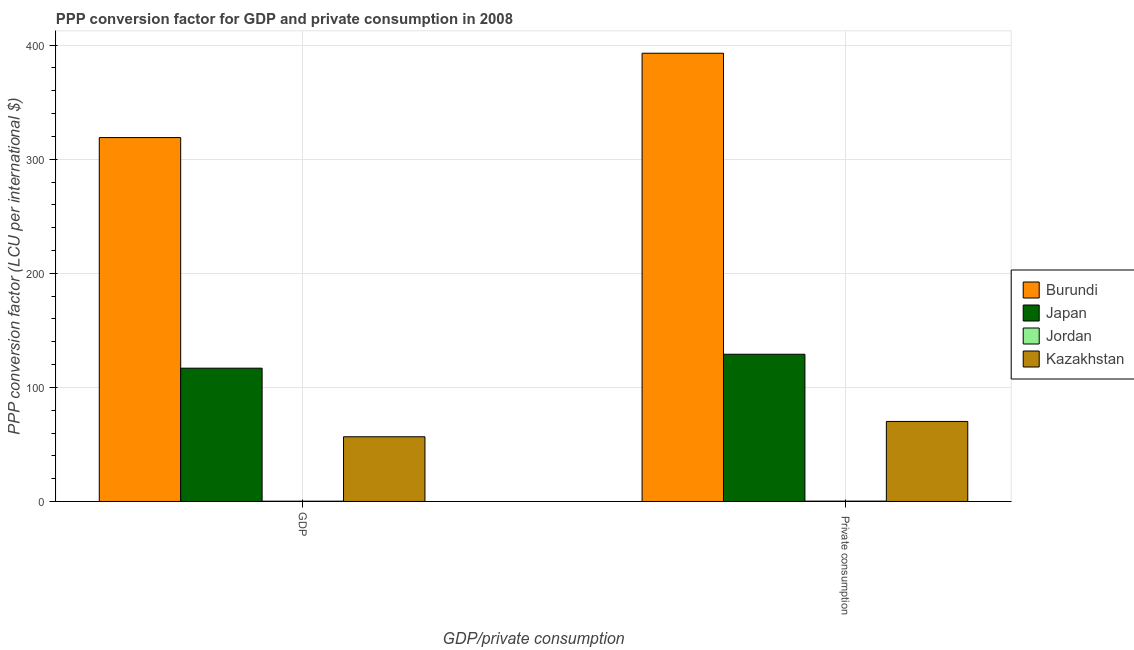How many different coloured bars are there?
Offer a very short reply. 4. How many groups of bars are there?
Offer a very short reply. 2. How many bars are there on the 1st tick from the left?
Your answer should be compact. 4. How many bars are there on the 2nd tick from the right?
Ensure brevity in your answer.  4. What is the label of the 1st group of bars from the left?
Provide a short and direct response. GDP. What is the ppp conversion factor for gdp in Jordan?
Your answer should be compact. 0.26. Across all countries, what is the maximum ppp conversion factor for gdp?
Make the answer very short. 318.99. Across all countries, what is the minimum ppp conversion factor for gdp?
Provide a short and direct response. 0.26. In which country was the ppp conversion factor for gdp maximum?
Make the answer very short. Burundi. In which country was the ppp conversion factor for private consumption minimum?
Provide a succinct answer. Jordan. What is the total ppp conversion factor for private consumption in the graph?
Give a very brief answer. 592.42. What is the difference between the ppp conversion factor for private consumption in Japan and that in Burundi?
Your answer should be very brief. -263.85. What is the difference between the ppp conversion factor for gdp in Japan and the ppp conversion factor for private consumption in Jordan?
Provide a short and direct response. 116.54. What is the average ppp conversion factor for private consumption per country?
Your response must be concise. 148.11. What is the difference between the ppp conversion factor for private consumption and ppp conversion factor for gdp in Kazakhstan?
Give a very brief answer. 13.42. What is the ratio of the ppp conversion factor for private consumption in Japan to that in Burundi?
Provide a short and direct response. 0.33. What does the 1st bar from the left in GDP represents?
Give a very brief answer. Burundi. What does the 1st bar from the right in GDP represents?
Offer a terse response. Kazakhstan. Are all the bars in the graph horizontal?
Your answer should be compact. No. How many countries are there in the graph?
Ensure brevity in your answer.  4. Does the graph contain any zero values?
Your answer should be compact. No. Where does the legend appear in the graph?
Your response must be concise. Center right. How many legend labels are there?
Ensure brevity in your answer.  4. What is the title of the graph?
Keep it short and to the point. PPP conversion factor for GDP and private consumption in 2008. What is the label or title of the X-axis?
Provide a succinct answer. GDP/private consumption. What is the label or title of the Y-axis?
Ensure brevity in your answer.  PPP conversion factor (LCU per international $). What is the PPP conversion factor (LCU per international $) of Burundi in GDP?
Offer a very short reply. 318.99. What is the PPP conversion factor (LCU per international $) of Japan in GDP?
Your response must be concise. 116.85. What is the PPP conversion factor (LCU per international $) of Jordan in GDP?
Provide a short and direct response. 0.26. What is the PPP conversion factor (LCU per international $) in Kazakhstan in GDP?
Your answer should be compact. 56.72. What is the PPP conversion factor (LCU per international $) of Burundi in  Private consumption?
Keep it short and to the point. 392.91. What is the PPP conversion factor (LCU per international $) in Japan in  Private consumption?
Provide a succinct answer. 129.06. What is the PPP conversion factor (LCU per international $) in Jordan in  Private consumption?
Offer a very short reply. 0.31. What is the PPP conversion factor (LCU per international $) in Kazakhstan in  Private consumption?
Give a very brief answer. 70.14. Across all GDP/private consumption, what is the maximum PPP conversion factor (LCU per international $) of Burundi?
Ensure brevity in your answer.  392.91. Across all GDP/private consumption, what is the maximum PPP conversion factor (LCU per international $) in Japan?
Provide a succinct answer. 129.06. Across all GDP/private consumption, what is the maximum PPP conversion factor (LCU per international $) of Jordan?
Your answer should be compact. 0.31. Across all GDP/private consumption, what is the maximum PPP conversion factor (LCU per international $) of Kazakhstan?
Offer a terse response. 70.14. Across all GDP/private consumption, what is the minimum PPP conversion factor (LCU per international $) of Burundi?
Provide a short and direct response. 318.99. Across all GDP/private consumption, what is the minimum PPP conversion factor (LCU per international $) of Japan?
Your response must be concise. 116.85. Across all GDP/private consumption, what is the minimum PPP conversion factor (LCU per international $) in Jordan?
Ensure brevity in your answer.  0.26. Across all GDP/private consumption, what is the minimum PPP conversion factor (LCU per international $) of Kazakhstan?
Give a very brief answer. 56.72. What is the total PPP conversion factor (LCU per international $) in Burundi in the graph?
Make the answer very short. 711.9. What is the total PPP conversion factor (LCU per international $) in Japan in the graph?
Offer a terse response. 245.91. What is the total PPP conversion factor (LCU per international $) in Jordan in the graph?
Keep it short and to the point. 0.56. What is the total PPP conversion factor (LCU per international $) in Kazakhstan in the graph?
Make the answer very short. 126.86. What is the difference between the PPP conversion factor (LCU per international $) of Burundi in GDP and that in  Private consumption?
Provide a succinct answer. -73.92. What is the difference between the PPP conversion factor (LCU per international $) of Japan in GDP and that in  Private consumption?
Offer a very short reply. -12.21. What is the difference between the PPP conversion factor (LCU per international $) in Jordan in GDP and that in  Private consumption?
Provide a short and direct response. -0.05. What is the difference between the PPP conversion factor (LCU per international $) in Kazakhstan in GDP and that in  Private consumption?
Your answer should be very brief. -13.42. What is the difference between the PPP conversion factor (LCU per international $) of Burundi in GDP and the PPP conversion factor (LCU per international $) of Japan in  Private consumption?
Give a very brief answer. 189.93. What is the difference between the PPP conversion factor (LCU per international $) in Burundi in GDP and the PPP conversion factor (LCU per international $) in Jordan in  Private consumption?
Give a very brief answer. 318.68. What is the difference between the PPP conversion factor (LCU per international $) in Burundi in GDP and the PPP conversion factor (LCU per international $) in Kazakhstan in  Private consumption?
Give a very brief answer. 248.84. What is the difference between the PPP conversion factor (LCU per international $) in Japan in GDP and the PPP conversion factor (LCU per international $) in Jordan in  Private consumption?
Offer a terse response. 116.54. What is the difference between the PPP conversion factor (LCU per international $) in Japan in GDP and the PPP conversion factor (LCU per international $) in Kazakhstan in  Private consumption?
Your response must be concise. 46.7. What is the difference between the PPP conversion factor (LCU per international $) in Jordan in GDP and the PPP conversion factor (LCU per international $) in Kazakhstan in  Private consumption?
Offer a terse response. -69.88. What is the average PPP conversion factor (LCU per international $) in Burundi per GDP/private consumption?
Your response must be concise. 355.95. What is the average PPP conversion factor (LCU per international $) of Japan per GDP/private consumption?
Make the answer very short. 122.95. What is the average PPP conversion factor (LCU per international $) in Jordan per GDP/private consumption?
Your answer should be compact. 0.28. What is the average PPP conversion factor (LCU per international $) in Kazakhstan per GDP/private consumption?
Provide a succinct answer. 63.43. What is the difference between the PPP conversion factor (LCU per international $) of Burundi and PPP conversion factor (LCU per international $) of Japan in GDP?
Your answer should be very brief. 202.14. What is the difference between the PPP conversion factor (LCU per international $) in Burundi and PPP conversion factor (LCU per international $) in Jordan in GDP?
Make the answer very short. 318.73. What is the difference between the PPP conversion factor (LCU per international $) in Burundi and PPP conversion factor (LCU per international $) in Kazakhstan in GDP?
Offer a terse response. 262.27. What is the difference between the PPP conversion factor (LCU per international $) of Japan and PPP conversion factor (LCU per international $) of Jordan in GDP?
Provide a succinct answer. 116.59. What is the difference between the PPP conversion factor (LCU per international $) in Japan and PPP conversion factor (LCU per international $) in Kazakhstan in GDP?
Provide a short and direct response. 60.13. What is the difference between the PPP conversion factor (LCU per international $) of Jordan and PPP conversion factor (LCU per international $) of Kazakhstan in GDP?
Your answer should be compact. -56.46. What is the difference between the PPP conversion factor (LCU per international $) of Burundi and PPP conversion factor (LCU per international $) of Japan in  Private consumption?
Ensure brevity in your answer.  263.85. What is the difference between the PPP conversion factor (LCU per international $) in Burundi and PPP conversion factor (LCU per international $) in Jordan in  Private consumption?
Your response must be concise. 392.6. What is the difference between the PPP conversion factor (LCU per international $) in Burundi and PPP conversion factor (LCU per international $) in Kazakhstan in  Private consumption?
Give a very brief answer. 322.77. What is the difference between the PPP conversion factor (LCU per international $) of Japan and PPP conversion factor (LCU per international $) of Jordan in  Private consumption?
Your answer should be compact. 128.75. What is the difference between the PPP conversion factor (LCU per international $) in Japan and PPP conversion factor (LCU per international $) in Kazakhstan in  Private consumption?
Give a very brief answer. 58.92. What is the difference between the PPP conversion factor (LCU per international $) of Jordan and PPP conversion factor (LCU per international $) of Kazakhstan in  Private consumption?
Provide a succinct answer. -69.84. What is the ratio of the PPP conversion factor (LCU per international $) of Burundi in GDP to that in  Private consumption?
Offer a very short reply. 0.81. What is the ratio of the PPP conversion factor (LCU per international $) in Japan in GDP to that in  Private consumption?
Offer a terse response. 0.91. What is the ratio of the PPP conversion factor (LCU per international $) of Jordan in GDP to that in  Private consumption?
Keep it short and to the point. 0.84. What is the ratio of the PPP conversion factor (LCU per international $) in Kazakhstan in GDP to that in  Private consumption?
Provide a short and direct response. 0.81. What is the difference between the highest and the second highest PPP conversion factor (LCU per international $) of Burundi?
Your answer should be compact. 73.92. What is the difference between the highest and the second highest PPP conversion factor (LCU per international $) in Japan?
Your response must be concise. 12.21. What is the difference between the highest and the second highest PPP conversion factor (LCU per international $) of Jordan?
Give a very brief answer. 0.05. What is the difference between the highest and the second highest PPP conversion factor (LCU per international $) of Kazakhstan?
Give a very brief answer. 13.42. What is the difference between the highest and the lowest PPP conversion factor (LCU per international $) of Burundi?
Offer a terse response. 73.92. What is the difference between the highest and the lowest PPP conversion factor (LCU per international $) of Japan?
Your answer should be very brief. 12.21. What is the difference between the highest and the lowest PPP conversion factor (LCU per international $) of Jordan?
Keep it short and to the point. 0.05. What is the difference between the highest and the lowest PPP conversion factor (LCU per international $) in Kazakhstan?
Provide a short and direct response. 13.42. 